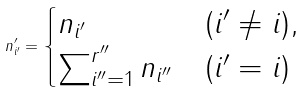Convert formula to latex. <formula><loc_0><loc_0><loc_500><loc_500>n _ { i ^ { \prime } } ^ { \prime } = \begin{cases} n _ { i ^ { \prime } } & ( i ^ { \prime } \neq i ) , \\ \sum _ { i ^ { \prime \prime } = 1 } ^ { r ^ { \prime \prime } } n _ { i ^ { \prime \prime } } & ( i ^ { \prime } = i ) \end{cases}</formula> 